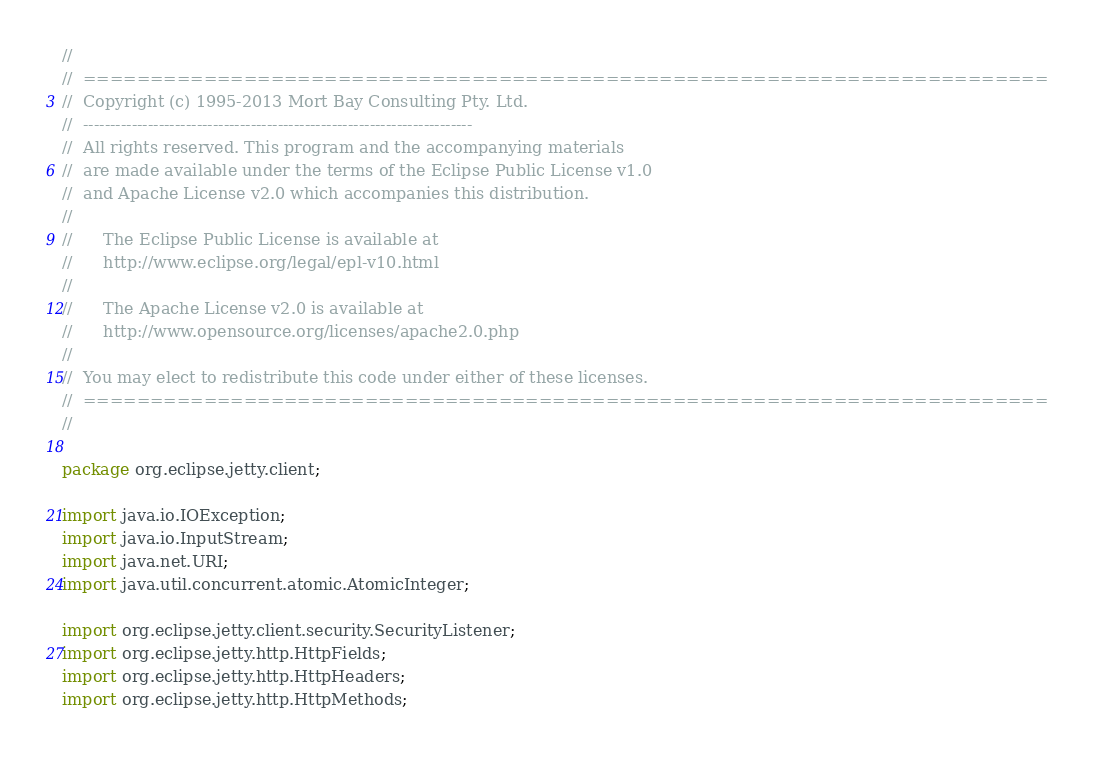Convert code to text. <code><loc_0><loc_0><loc_500><loc_500><_Java_>//
//  ========================================================================
//  Copyright (c) 1995-2013 Mort Bay Consulting Pty. Ltd.
//  ------------------------------------------------------------------------
//  All rights reserved. This program and the accompanying materials
//  are made available under the terms of the Eclipse Public License v1.0
//  and Apache License v2.0 which accompanies this distribution.
//
//      The Eclipse Public License is available at
//      http://www.eclipse.org/legal/epl-v10.html
//
//      The Apache License v2.0 is available at
//      http://www.opensource.org/licenses/apache2.0.php
//
//  You may elect to redistribute this code under either of these licenses.
//  ========================================================================
//

package org.eclipse.jetty.client;

import java.io.IOException;
import java.io.InputStream;
import java.net.URI;
import java.util.concurrent.atomic.AtomicInteger;

import org.eclipse.jetty.client.security.SecurityListener;
import org.eclipse.jetty.http.HttpFields;
import org.eclipse.jetty.http.HttpHeaders;
import org.eclipse.jetty.http.HttpMethods;</code> 